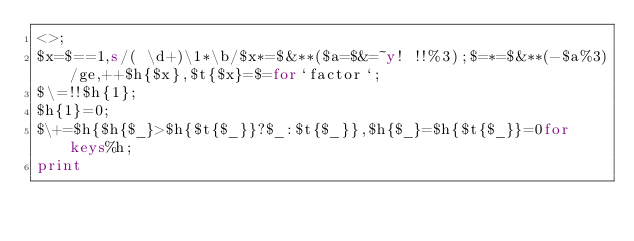Convert code to text. <code><loc_0><loc_0><loc_500><loc_500><_Perl_><>;
$x=$==1,s/( \d+)\1*\b/$x*=$&**($a=$&=~y! !!%3);$=*=$&**(-$a%3)/ge,++$h{$x},$t{$x}=$=for`factor`;
$\=!!$h{1};
$h{1}=0;
$\+=$h{$h{$_}>$h{$t{$_}}?$_:$t{$_}},$h{$_}=$h{$t{$_}}=0for keys%h;
print
</code> 